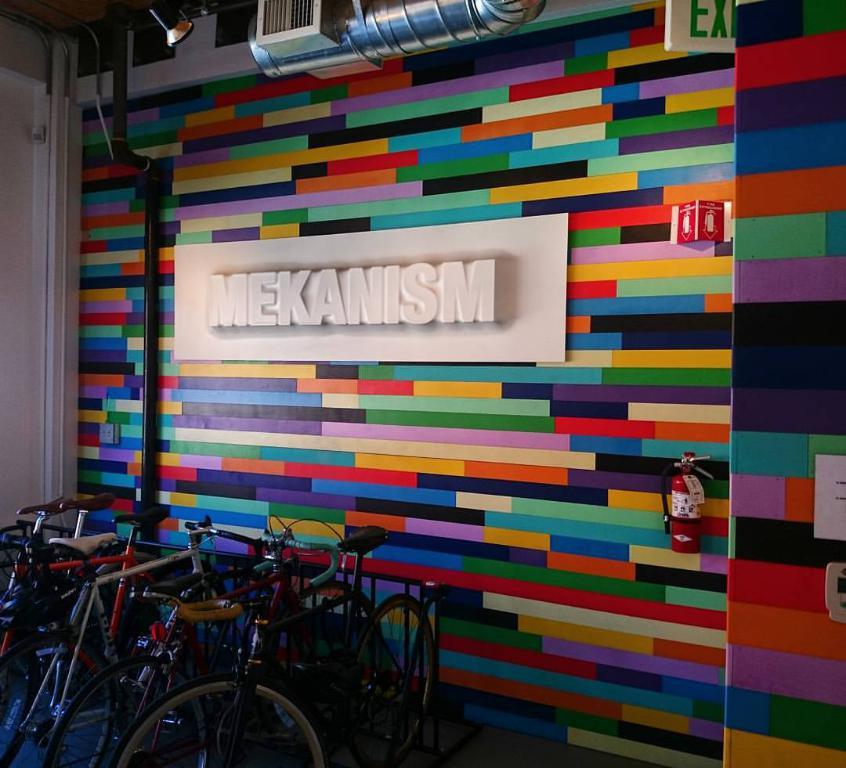<image>
Relay a brief, clear account of the picture shown. Colorful wall with the word "MEKANISM" on it and some bikes in front. 